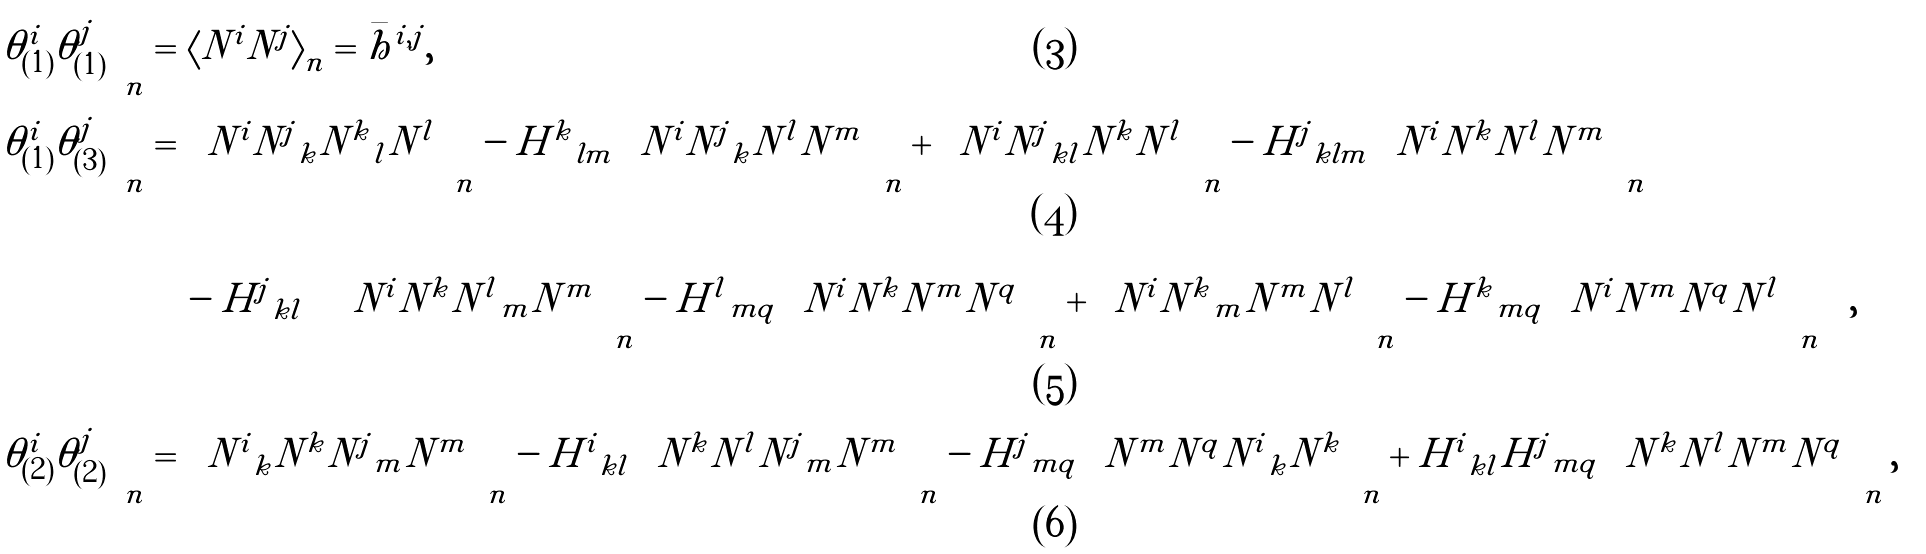Convert formula to latex. <formula><loc_0><loc_0><loc_500><loc_500>\left \langle \theta ^ { i } _ { ( 1 ) } \theta ^ { j } _ { ( 1 ) } \right \rangle _ { n } = \, & \left \langle N ^ { i } N ^ { j } \right \rangle _ { n } = \bar { h } ^ { i , j } , \\ \left \langle \theta ^ { i } _ { ( 1 ) } \theta ^ { j } _ { ( 3 ) } \right \rangle _ { n } = \, & \left \langle N ^ { i } { N ^ { j } } _ { k } { N ^ { k } } _ { l } N ^ { l } \right \rangle _ { n } - { H ^ { k } } _ { l m } \left \langle N ^ { i } { N ^ { j } } _ { k } N ^ { l } N ^ { m } \right \rangle _ { n } + \left \langle N ^ { i } { N ^ { j } } _ { k l } N ^ { k } N ^ { l } \right \rangle _ { n } - { H ^ { j } } _ { k l m } \left \langle N ^ { i } N ^ { k } N ^ { l } N ^ { m } \right \rangle _ { n } \\ & - { H ^ { j } } _ { k l } \left ( \left \langle N ^ { i } N ^ { k } { N ^ { l } } _ { m } N ^ { m } \right \rangle _ { n } - { H ^ { l } } _ { m q } \left \langle N ^ { i } N ^ { k } N ^ { m } N ^ { q } \right \rangle _ { n } + \left \langle N ^ { i } { N ^ { k } } _ { m } N ^ { m } N ^ { l } \right \rangle _ { n } - { H ^ { k } } _ { m q } \left \langle N ^ { i } N ^ { m } N ^ { q } N ^ { l } \right \rangle _ { n } \right ) , \\ \left \langle \theta ^ { i } _ { ( 2 ) } \theta ^ { j } _ { ( 2 ) } \right \rangle _ { n } = \, & \left \langle { N ^ { i } } _ { k } N ^ { k } { N ^ { j } } _ { m } N ^ { m } \right \rangle _ { n } - { H ^ { i } } _ { k l } \left \langle N ^ { k } N ^ { l } { N ^ { j } } _ { m } N ^ { m } \right \rangle _ { n } - { H ^ { j } } _ { m q } \left \langle N ^ { m } N ^ { q } { N ^ { i } } _ { k } N ^ { k } \right \rangle _ { n } + { H ^ { i } } _ { k l } { H ^ { j } } _ { m q } \left \langle N ^ { k } N ^ { l } N ^ { m } N ^ { q } \right \rangle _ { n } ,</formula> 